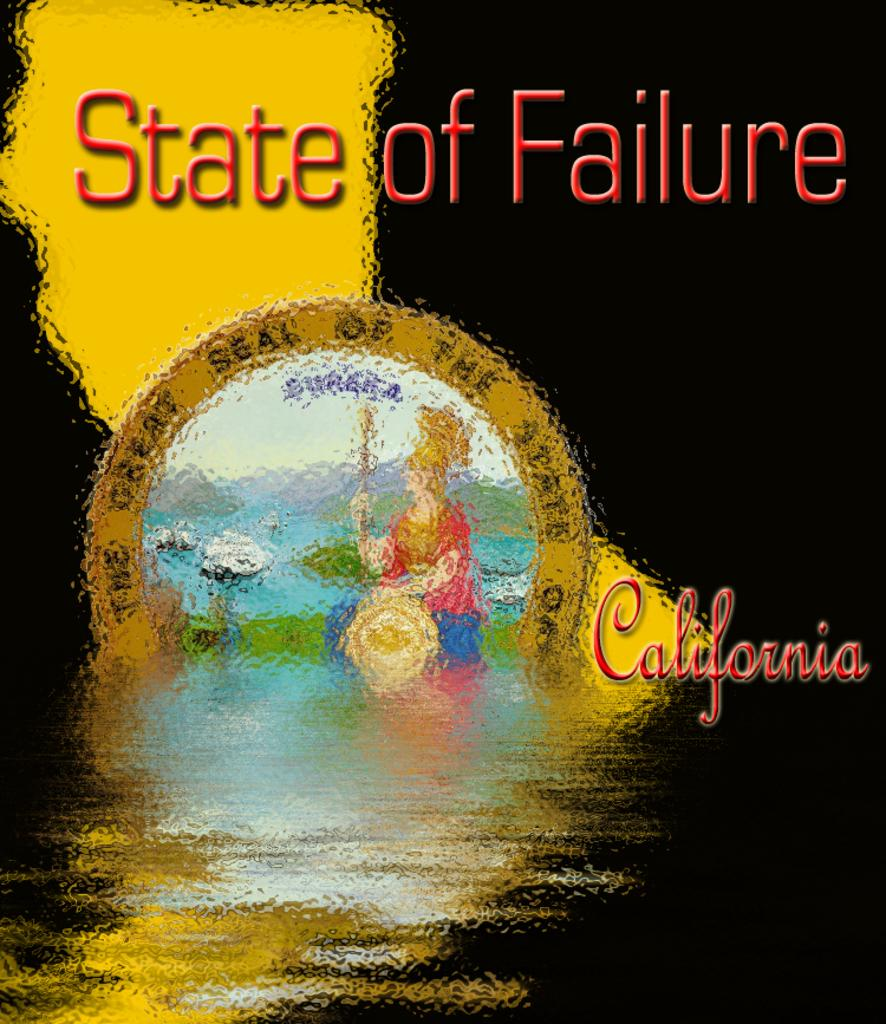<image>
Create a compact narrative representing the image presented. The poster here is for the state of California 